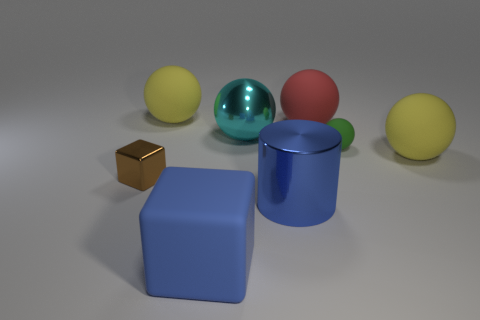What is the material of the big blue cube?
Ensure brevity in your answer.  Rubber. How many objects are either brown things or tiny cylinders?
Provide a short and direct response. 1. There is a yellow sphere left of the big shiny cylinder; is it the same size as the cube that is behind the large blue rubber cube?
Ensure brevity in your answer.  No. How many other objects are there of the same size as the cyan object?
Ensure brevity in your answer.  5. What number of objects are either big things on the left side of the big blue matte block or yellow things that are right of the cyan thing?
Give a very brief answer. 2. Is the red thing made of the same material as the large yellow sphere that is to the right of the blue shiny cylinder?
Your answer should be compact. Yes. What number of other objects are there of the same shape as the large cyan object?
Offer a terse response. 4. There is a yellow thing behind the matte sphere right of the tiny green matte thing that is behind the big cylinder; what is it made of?
Your answer should be compact. Rubber. Is the number of red rubber things on the left side of the blue cylinder the same as the number of red rubber objects?
Provide a succinct answer. No. Is the large yellow ball that is right of the large cylinder made of the same material as the block in front of the tiny block?
Give a very brief answer. Yes. 